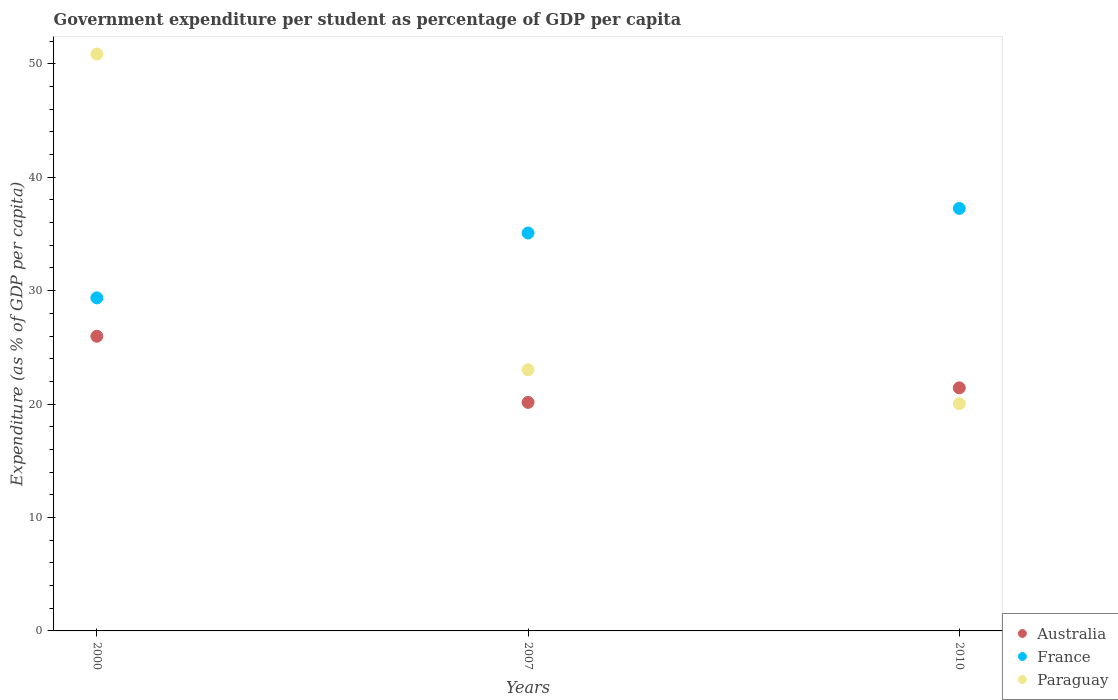Is the number of dotlines equal to the number of legend labels?
Give a very brief answer. Yes. What is the percentage of expenditure per student in France in 2010?
Keep it short and to the point. 37.25. Across all years, what is the maximum percentage of expenditure per student in France?
Make the answer very short. 37.25. Across all years, what is the minimum percentage of expenditure per student in Australia?
Provide a short and direct response. 20.15. In which year was the percentage of expenditure per student in Paraguay maximum?
Ensure brevity in your answer.  2000. In which year was the percentage of expenditure per student in France minimum?
Make the answer very short. 2000. What is the total percentage of expenditure per student in Australia in the graph?
Your answer should be compact. 67.55. What is the difference between the percentage of expenditure per student in Paraguay in 2007 and that in 2010?
Offer a very short reply. 2.99. What is the difference between the percentage of expenditure per student in France in 2007 and the percentage of expenditure per student in Paraguay in 2010?
Provide a short and direct response. 15.05. What is the average percentage of expenditure per student in Paraguay per year?
Make the answer very short. 31.3. In the year 2000, what is the difference between the percentage of expenditure per student in Australia and percentage of expenditure per student in France?
Provide a short and direct response. -3.39. In how many years, is the percentage of expenditure per student in Paraguay greater than 14 %?
Your answer should be very brief. 3. What is the ratio of the percentage of expenditure per student in France in 2000 to that in 2010?
Offer a terse response. 0.79. What is the difference between the highest and the second highest percentage of expenditure per student in France?
Your response must be concise. 2.17. What is the difference between the highest and the lowest percentage of expenditure per student in Paraguay?
Provide a succinct answer. 30.82. In how many years, is the percentage of expenditure per student in France greater than the average percentage of expenditure per student in France taken over all years?
Provide a short and direct response. 2. Is the sum of the percentage of expenditure per student in France in 2007 and 2010 greater than the maximum percentage of expenditure per student in Australia across all years?
Provide a succinct answer. Yes. Does the percentage of expenditure per student in France monotonically increase over the years?
Give a very brief answer. Yes. What is the difference between two consecutive major ticks on the Y-axis?
Your answer should be compact. 10. Are the values on the major ticks of Y-axis written in scientific E-notation?
Keep it short and to the point. No. Does the graph contain any zero values?
Keep it short and to the point. No. Does the graph contain grids?
Your response must be concise. No. Where does the legend appear in the graph?
Your answer should be compact. Bottom right. What is the title of the graph?
Keep it short and to the point. Government expenditure per student as percentage of GDP per capita. What is the label or title of the X-axis?
Offer a very short reply. Years. What is the label or title of the Y-axis?
Make the answer very short. Expenditure (as % of GDP per capita). What is the Expenditure (as % of GDP per capita) of Australia in 2000?
Provide a succinct answer. 25.98. What is the Expenditure (as % of GDP per capita) of France in 2000?
Your answer should be very brief. 29.36. What is the Expenditure (as % of GDP per capita) in Paraguay in 2000?
Give a very brief answer. 50.86. What is the Expenditure (as % of GDP per capita) of Australia in 2007?
Your answer should be very brief. 20.15. What is the Expenditure (as % of GDP per capita) in France in 2007?
Make the answer very short. 35.08. What is the Expenditure (as % of GDP per capita) in Paraguay in 2007?
Offer a very short reply. 23.02. What is the Expenditure (as % of GDP per capita) in Australia in 2010?
Offer a terse response. 21.43. What is the Expenditure (as % of GDP per capita) of France in 2010?
Your response must be concise. 37.25. What is the Expenditure (as % of GDP per capita) in Paraguay in 2010?
Provide a succinct answer. 20.03. Across all years, what is the maximum Expenditure (as % of GDP per capita) of Australia?
Provide a succinct answer. 25.98. Across all years, what is the maximum Expenditure (as % of GDP per capita) of France?
Your answer should be compact. 37.25. Across all years, what is the maximum Expenditure (as % of GDP per capita) in Paraguay?
Make the answer very short. 50.86. Across all years, what is the minimum Expenditure (as % of GDP per capita) of Australia?
Offer a terse response. 20.15. Across all years, what is the minimum Expenditure (as % of GDP per capita) in France?
Make the answer very short. 29.36. Across all years, what is the minimum Expenditure (as % of GDP per capita) of Paraguay?
Offer a very short reply. 20.03. What is the total Expenditure (as % of GDP per capita) in Australia in the graph?
Ensure brevity in your answer.  67.55. What is the total Expenditure (as % of GDP per capita) in France in the graph?
Your answer should be compact. 101.69. What is the total Expenditure (as % of GDP per capita) in Paraguay in the graph?
Ensure brevity in your answer.  93.91. What is the difference between the Expenditure (as % of GDP per capita) of Australia in 2000 and that in 2007?
Your response must be concise. 5.83. What is the difference between the Expenditure (as % of GDP per capita) of France in 2000 and that in 2007?
Give a very brief answer. -5.72. What is the difference between the Expenditure (as % of GDP per capita) in Paraguay in 2000 and that in 2007?
Offer a very short reply. 27.83. What is the difference between the Expenditure (as % of GDP per capita) in Australia in 2000 and that in 2010?
Your answer should be very brief. 4.55. What is the difference between the Expenditure (as % of GDP per capita) in France in 2000 and that in 2010?
Provide a short and direct response. -7.88. What is the difference between the Expenditure (as % of GDP per capita) in Paraguay in 2000 and that in 2010?
Provide a succinct answer. 30.82. What is the difference between the Expenditure (as % of GDP per capita) in Australia in 2007 and that in 2010?
Your response must be concise. -1.28. What is the difference between the Expenditure (as % of GDP per capita) of France in 2007 and that in 2010?
Your answer should be compact. -2.17. What is the difference between the Expenditure (as % of GDP per capita) in Paraguay in 2007 and that in 2010?
Your answer should be compact. 2.99. What is the difference between the Expenditure (as % of GDP per capita) of Australia in 2000 and the Expenditure (as % of GDP per capita) of France in 2007?
Give a very brief answer. -9.1. What is the difference between the Expenditure (as % of GDP per capita) in Australia in 2000 and the Expenditure (as % of GDP per capita) in Paraguay in 2007?
Give a very brief answer. 2.96. What is the difference between the Expenditure (as % of GDP per capita) in France in 2000 and the Expenditure (as % of GDP per capita) in Paraguay in 2007?
Make the answer very short. 6.34. What is the difference between the Expenditure (as % of GDP per capita) in Australia in 2000 and the Expenditure (as % of GDP per capita) in France in 2010?
Your response must be concise. -11.27. What is the difference between the Expenditure (as % of GDP per capita) in Australia in 2000 and the Expenditure (as % of GDP per capita) in Paraguay in 2010?
Provide a succinct answer. 5.94. What is the difference between the Expenditure (as % of GDP per capita) of France in 2000 and the Expenditure (as % of GDP per capita) of Paraguay in 2010?
Provide a short and direct response. 9.33. What is the difference between the Expenditure (as % of GDP per capita) of Australia in 2007 and the Expenditure (as % of GDP per capita) of France in 2010?
Provide a short and direct response. -17.1. What is the difference between the Expenditure (as % of GDP per capita) of Australia in 2007 and the Expenditure (as % of GDP per capita) of Paraguay in 2010?
Your response must be concise. 0.11. What is the difference between the Expenditure (as % of GDP per capita) in France in 2007 and the Expenditure (as % of GDP per capita) in Paraguay in 2010?
Give a very brief answer. 15.05. What is the average Expenditure (as % of GDP per capita) in Australia per year?
Offer a terse response. 22.52. What is the average Expenditure (as % of GDP per capita) of France per year?
Keep it short and to the point. 33.9. What is the average Expenditure (as % of GDP per capita) in Paraguay per year?
Your answer should be very brief. 31.3. In the year 2000, what is the difference between the Expenditure (as % of GDP per capita) of Australia and Expenditure (as % of GDP per capita) of France?
Your answer should be compact. -3.39. In the year 2000, what is the difference between the Expenditure (as % of GDP per capita) in Australia and Expenditure (as % of GDP per capita) in Paraguay?
Provide a succinct answer. -24.88. In the year 2000, what is the difference between the Expenditure (as % of GDP per capita) of France and Expenditure (as % of GDP per capita) of Paraguay?
Give a very brief answer. -21.49. In the year 2007, what is the difference between the Expenditure (as % of GDP per capita) of Australia and Expenditure (as % of GDP per capita) of France?
Provide a short and direct response. -14.93. In the year 2007, what is the difference between the Expenditure (as % of GDP per capita) of Australia and Expenditure (as % of GDP per capita) of Paraguay?
Offer a very short reply. -2.87. In the year 2007, what is the difference between the Expenditure (as % of GDP per capita) in France and Expenditure (as % of GDP per capita) in Paraguay?
Your answer should be very brief. 12.06. In the year 2010, what is the difference between the Expenditure (as % of GDP per capita) in Australia and Expenditure (as % of GDP per capita) in France?
Keep it short and to the point. -15.82. In the year 2010, what is the difference between the Expenditure (as % of GDP per capita) of Australia and Expenditure (as % of GDP per capita) of Paraguay?
Offer a terse response. 1.4. In the year 2010, what is the difference between the Expenditure (as % of GDP per capita) in France and Expenditure (as % of GDP per capita) in Paraguay?
Your answer should be very brief. 17.21. What is the ratio of the Expenditure (as % of GDP per capita) of Australia in 2000 to that in 2007?
Provide a succinct answer. 1.29. What is the ratio of the Expenditure (as % of GDP per capita) of France in 2000 to that in 2007?
Offer a terse response. 0.84. What is the ratio of the Expenditure (as % of GDP per capita) in Paraguay in 2000 to that in 2007?
Give a very brief answer. 2.21. What is the ratio of the Expenditure (as % of GDP per capita) in Australia in 2000 to that in 2010?
Your answer should be very brief. 1.21. What is the ratio of the Expenditure (as % of GDP per capita) in France in 2000 to that in 2010?
Your answer should be compact. 0.79. What is the ratio of the Expenditure (as % of GDP per capita) in Paraguay in 2000 to that in 2010?
Ensure brevity in your answer.  2.54. What is the ratio of the Expenditure (as % of GDP per capita) in Australia in 2007 to that in 2010?
Keep it short and to the point. 0.94. What is the ratio of the Expenditure (as % of GDP per capita) of France in 2007 to that in 2010?
Make the answer very short. 0.94. What is the ratio of the Expenditure (as % of GDP per capita) in Paraguay in 2007 to that in 2010?
Your answer should be very brief. 1.15. What is the difference between the highest and the second highest Expenditure (as % of GDP per capita) of Australia?
Offer a very short reply. 4.55. What is the difference between the highest and the second highest Expenditure (as % of GDP per capita) of France?
Ensure brevity in your answer.  2.17. What is the difference between the highest and the second highest Expenditure (as % of GDP per capita) in Paraguay?
Provide a succinct answer. 27.83. What is the difference between the highest and the lowest Expenditure (as % of GDP per capita) of Australia?
Offer a very short reply. 5.83. What is the difference between the highest and the lowest Expenditure (as % of GDP per capita) of France?
Ensure brevity in your answer.  7.88. What is the difference between the highest and the lowest Expenditure (as % of GDP per capita) of Paraguay?
Keep it short and to the point. 30.82. 